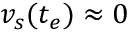Convert formula to latex. <formula><loc_0><loc_0><loc_500><loc_500>v _ { s } ( t _ { e } ) \approx 0</formula> 